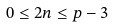Convert formula to latex. <formula><loc_0><loc_0><loc_500><loc_500>0 \leq 2 n \leq p - 3</formula> 